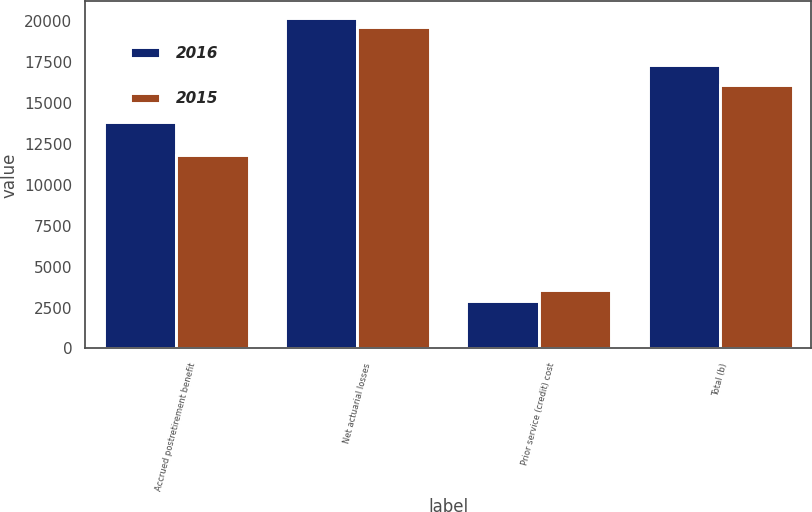Convert chart. <chart><loc_0><loc_0><loc_500><loc_500><stacked_bar_chart><ecel><fcel>Accrued postretirement benefit<fcel>Net actuarial losses<fcel>Prior service (credit) cost<fcel>Total (b)<nl><fcel>2016<fcel>13855<fcel>20184<fcel>2896<fcel>17288<nl><fcel>2015<fcel>11807<fcel>19632<fcel>3565<fcel>16067<nl></chart> 